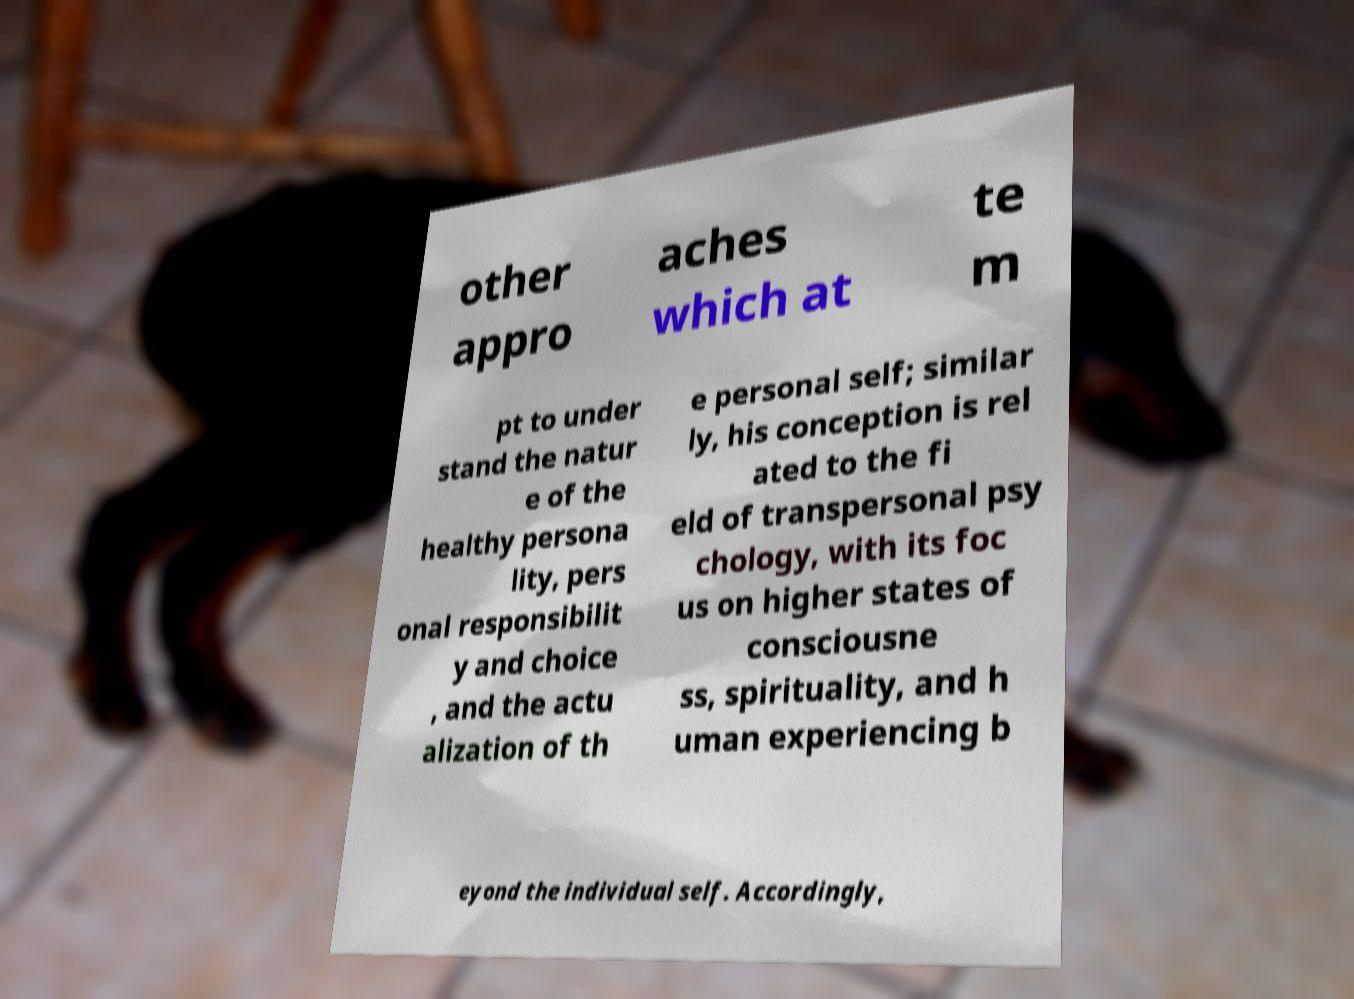I need the written content from this picture converted into text. Can you do that? other appro aches which at te m pt to under stand the natur e of the healthy persona lity, pers onal responsibilit y and choice , and the actu alization of th e personal self; similar ly, his conception is rel ated to the fi eld of transpersonal psy chology, with its foc us on higher states of consciousne ss, spirituality, and h uman experiencing b eyond the individual self. Accordingly, 